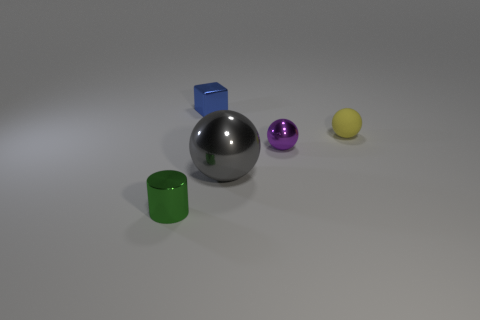Subtract 1 balls. How many balls are left? 2 Add 1 matte balls. How many objects exist? 6 Add 1 big metallic objects. How many big metallic objects exist? 2 Subtract 0 cyan spheres. How many objects are left? 5 Subtract all balls. How many objects are left? 2 Subtract all small objects. Subtract all big blue shiny cubes. How many objects are left? 1 Add 3 small purple balls. How many small purple balls are left? 4 